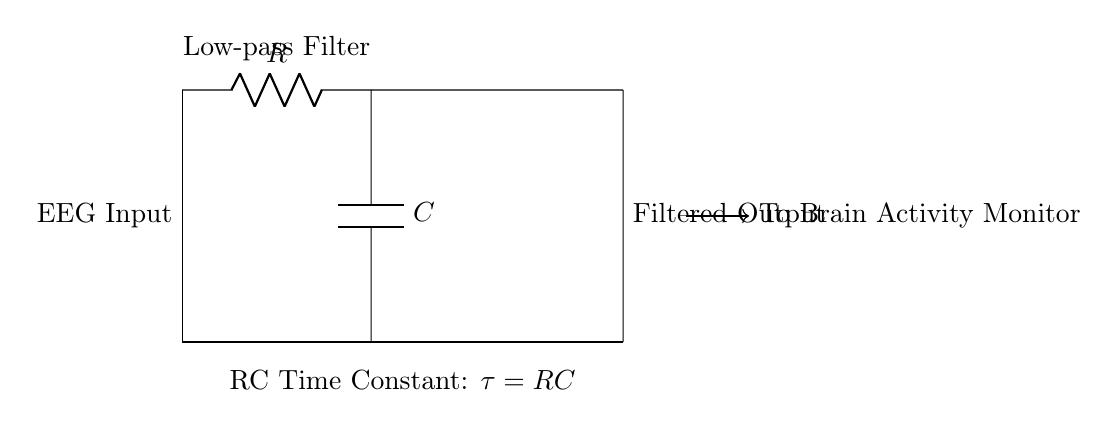What type of filter is represented by this circuit? The circuit diagram indicates a low-pass filter due to the arrangement of the resistor and capacitor, which allows low-frequency signals to pass while attenuating high-frequency signals.
Answer: Low-pass filter What are the components present in this circuit? The circuit consists of a resistor and a capacitor; these are the two main components used to filter the input EEG signal.
Answer: Resistor, Capacitor What is the role of the capacitor in this RC circuit? The capacitor stores electrical energy and helps control the time constant of the circuit, which determines how quickly it responds to changes in the input voltage.
Answer: Energy storage What is the time constant in this circuit? The time constant, denoted as tau, is calculated as the product of the resistance and the capacitance, represented mathematically as tau equals R times C.
Answer: RC How does increasing resistance affect the filtering of the EEG signal? Increasing the resistance will increase the time constant, which makes the circuit respond more slowly to changes in the input voltage, filtering out higher frequency components more effectively.
Answer: Filters more What happens to high-frequency noise in this circuit? The high-frequency noise is attenuated; because the low-pass filter configuration reduces the amplitude of signals that exceed the cutoff frequency determined by the resistor and capacitor values.
Answer: Attenuated 